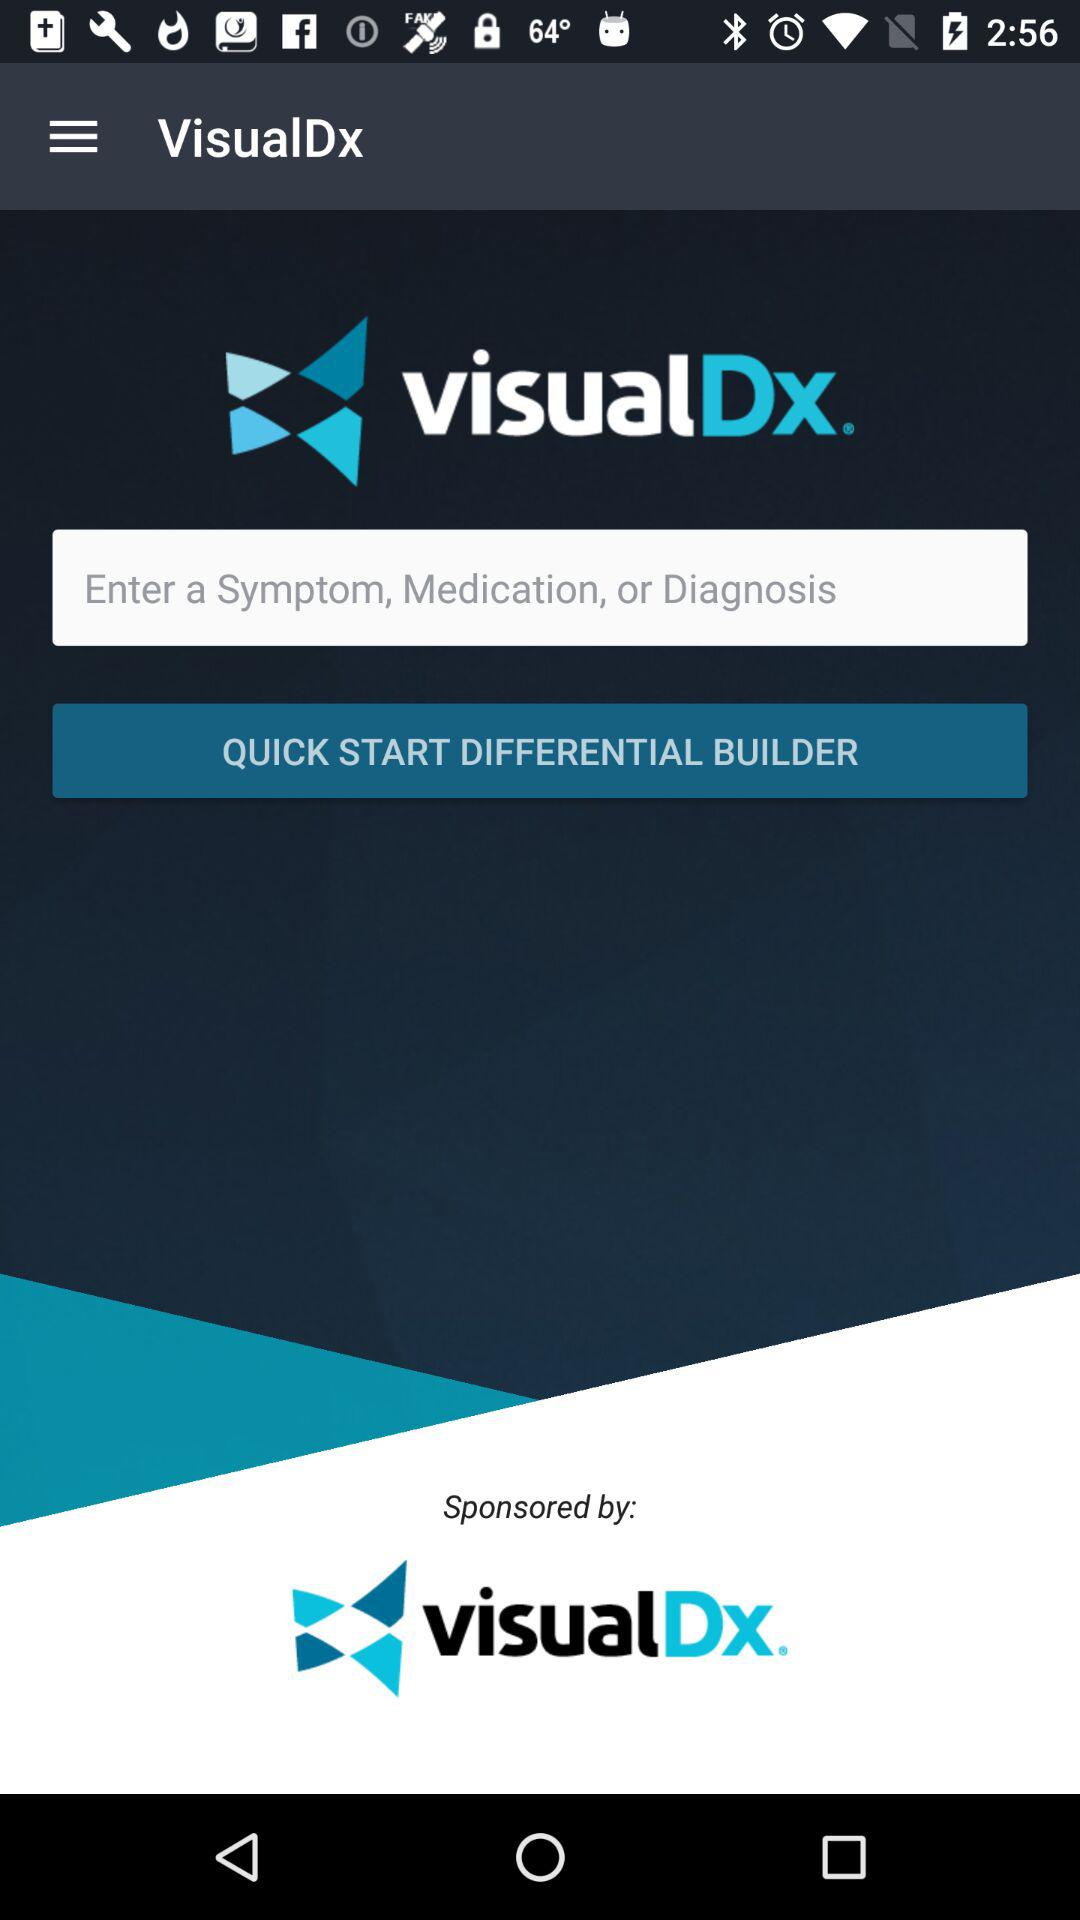What is the application name? The application name is "VisualDx". 